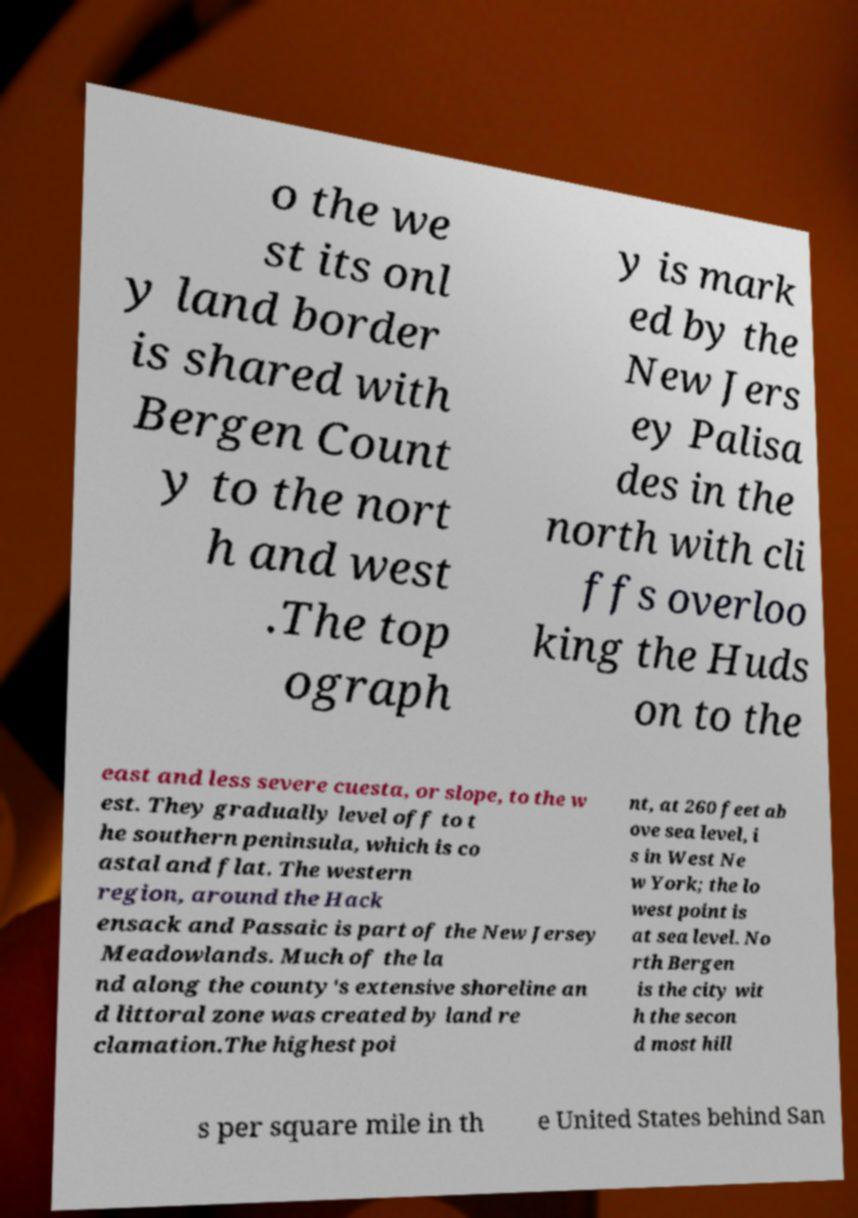What messages or text are displayed in this image? I need them in a readable, typed format. o the we st its onl y land border is shared with Bergen Count y to the nort h and west .The top ograph y is mark ed by the New Jers ey Palisa des in the north with cli ffs overloo king the Huds on to the east and less severe cuesta, or slope, to the w est. They gradually level off to t he southern peninsula, which is co astal and flat. The western region, around the Hack ensack and Passaic is part of the New Jersey Meadowlands. Much of the la nd along the county's extensive shoreline an d littoral zone was created by land re clamation.The highest poi nt, at 260 feet ab ove sea level, i s in West Ne w York; the lo west point is at sea level. No rth Bergen is the city wit h the secon d most hill s per square mile in th e United States behind San 